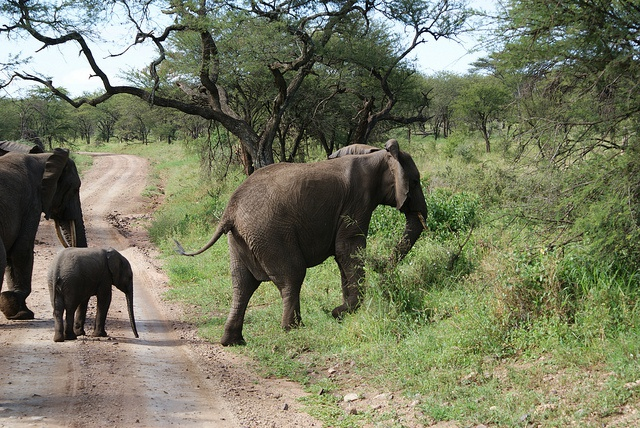Describe the objects in this image and their specific colors. I can see elephant in lightblue, black, and gray tones, elephant in lightblue, black, gray, and darkgray tones, elephant in lightblue, black, gray, and darkgray tones, and elephant in lightblue, black, darkgray, and gray tones in this image. 